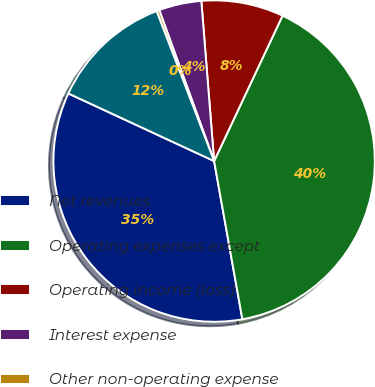<chart> <loc_0><loc_0><loc_500><loc_500><pie_chart><fcel>Net revenues<fcel>Operating expenses except<fcel>Operating income (loss)<fcel>Interest expense<fcel>Other non-operating expense<fcel>Net loss<nl><fcel>34.73%<fcel>40.19%<fcel>8.27%<fcel>4.28%<fcel>0.28%<fcel>12.26%<nl></chart> 